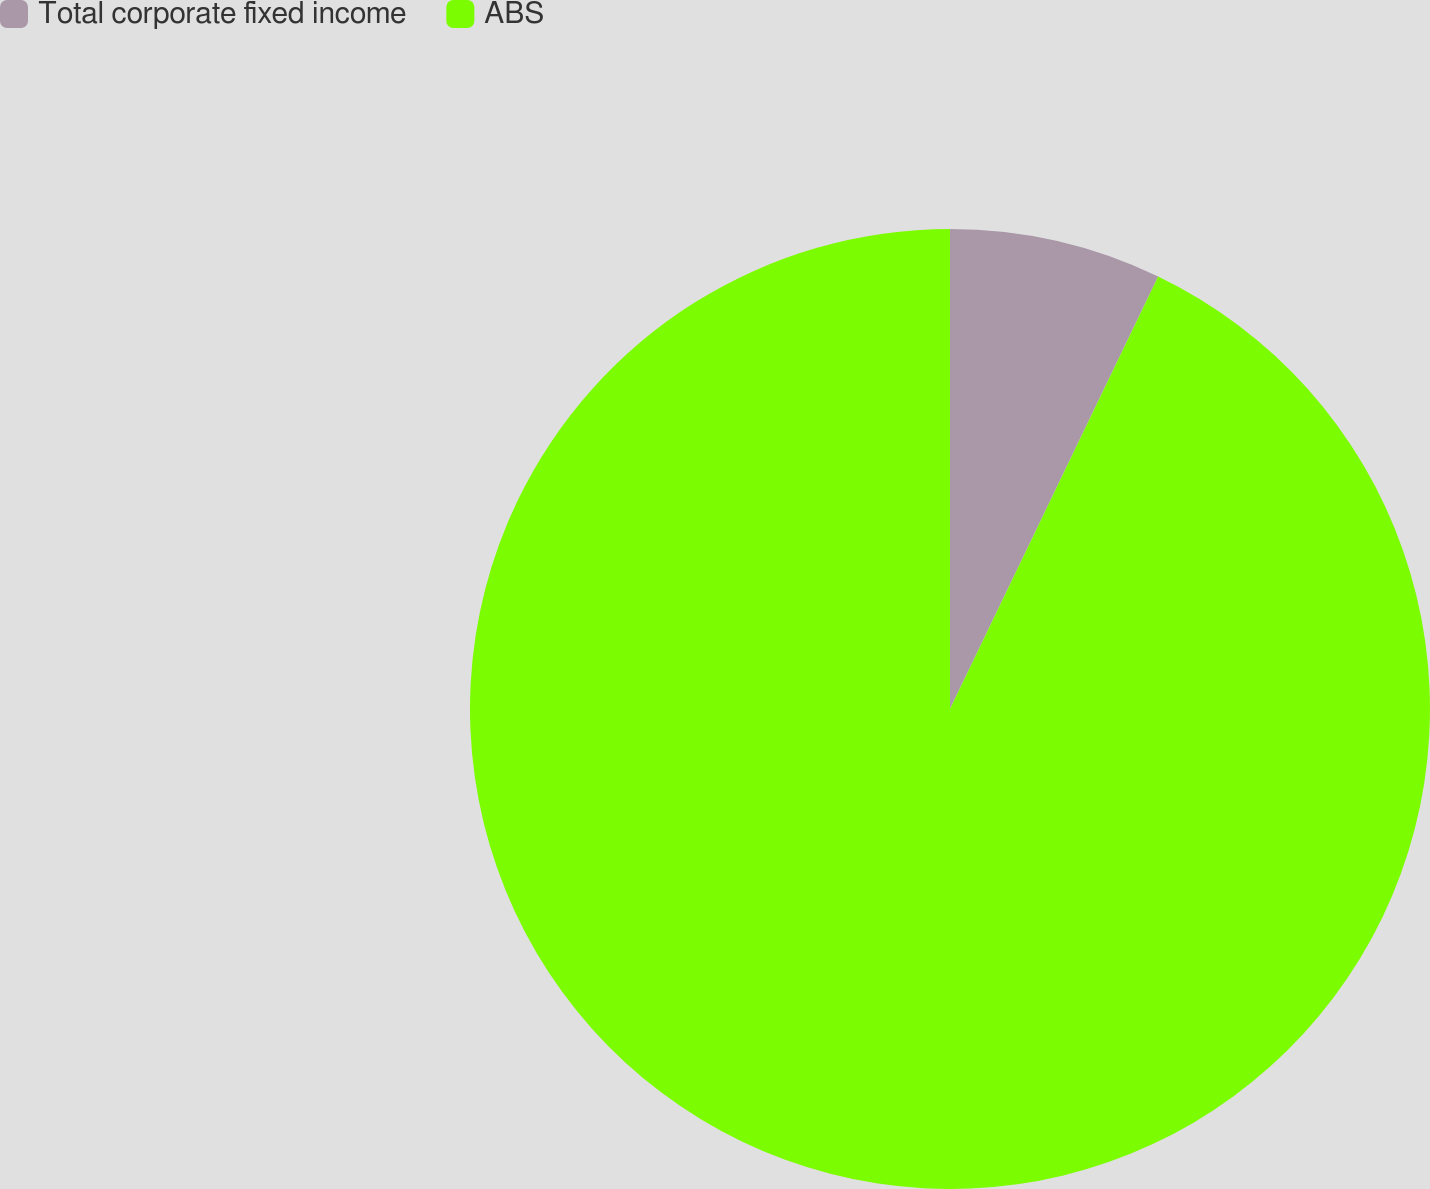<chart> <loc_0><loc_0><loc_500><loc_500><pie_chart><fcel>Total corporate fixed income<fcel>ABS<nl><fcel>7.14%<fcel>92.86%<nl></chart> 